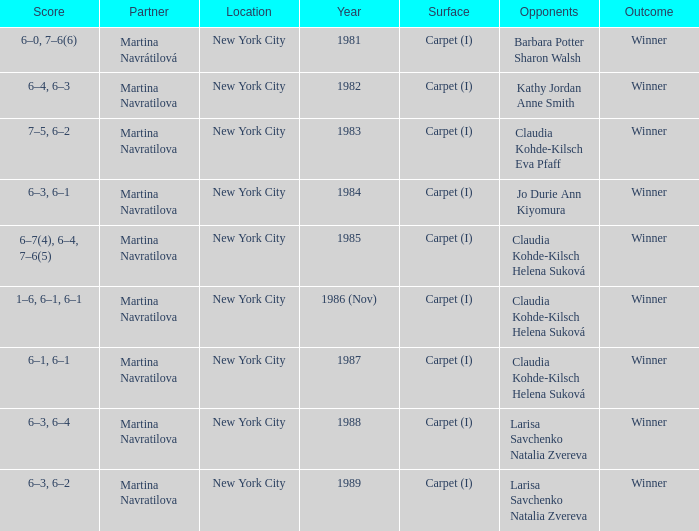What was the outcome for the match in 1989? Winner. 